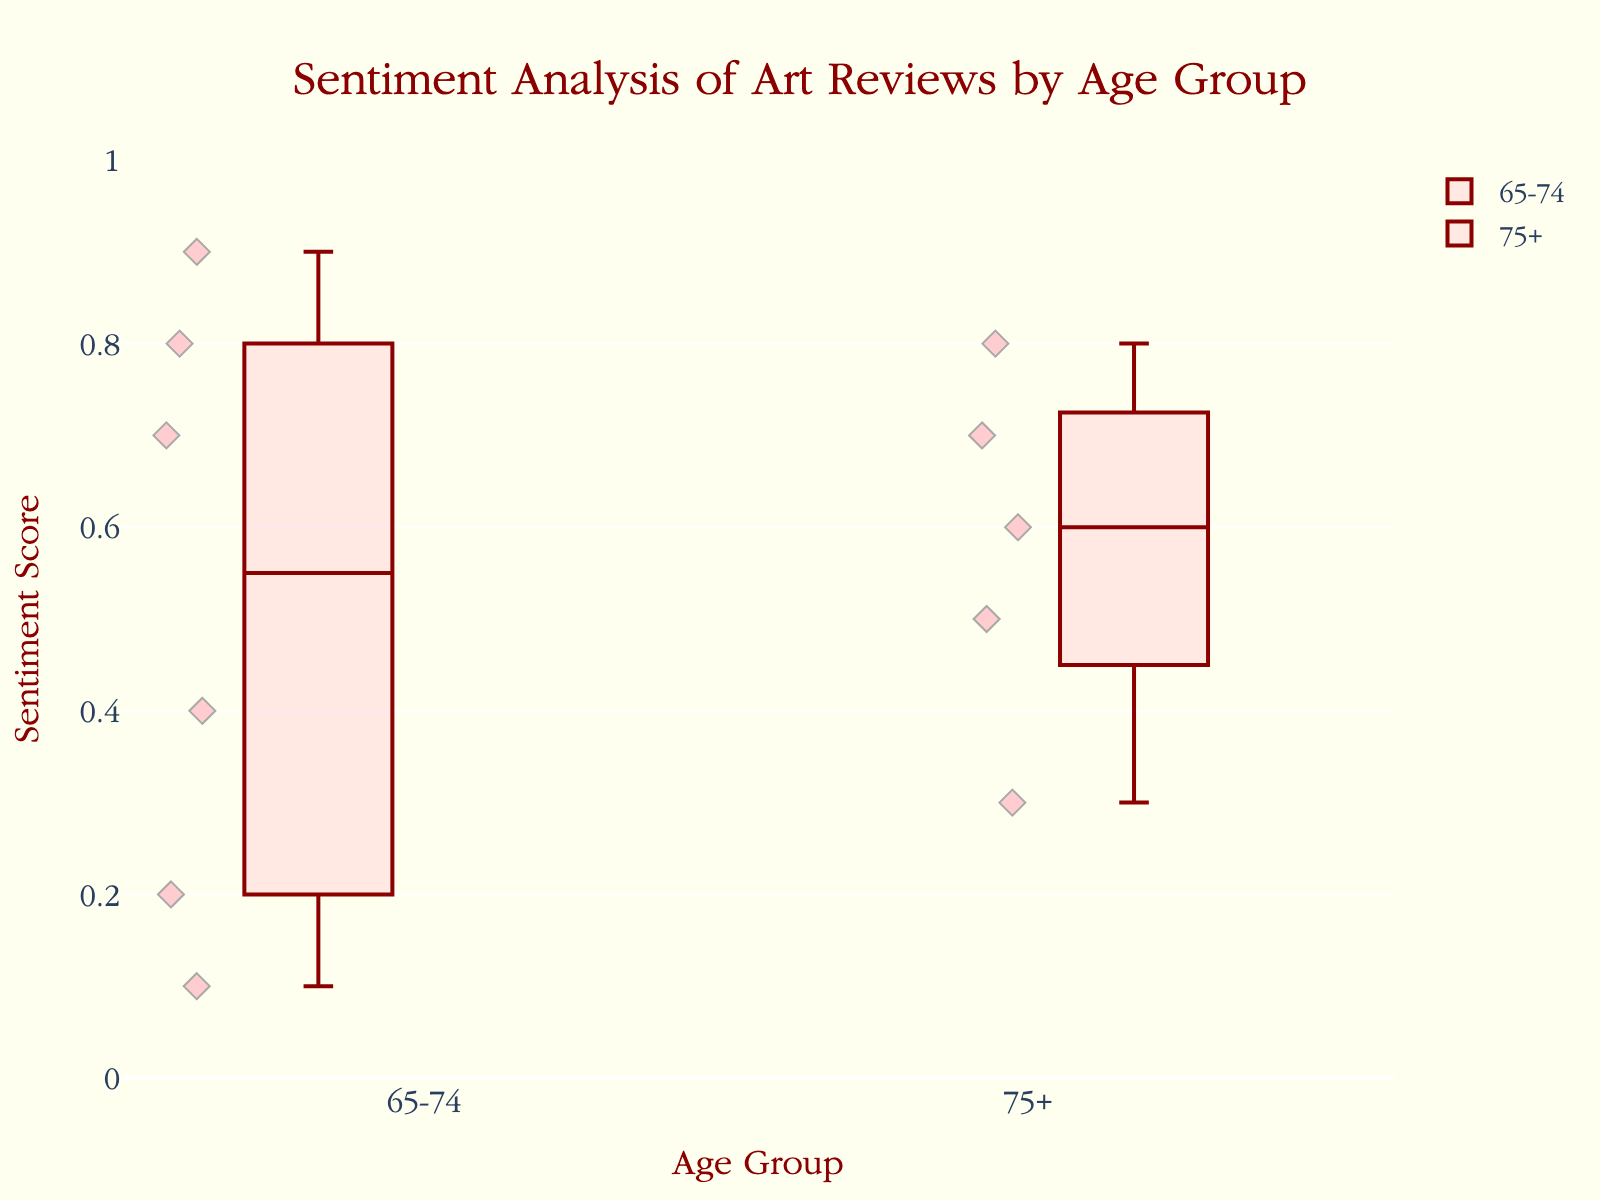what is the title of the plot? The title can be found at the top of the plot, and it reads "Sentiment Analysis of Art Reviews by Age Group."
Answer: Sentiment Analysis of Art Reviews by Age Group How many unique age groups are there? By identifying the different categories on the x-axis, you can see that there are two unique age groups: "65-74" and "75+."
Answer: 2 What is the maximum sentiment score value depicted for the 65-74 age group? Look at the highest point in the box plot under the "65-74" category on the x-axis, which reaches up to 0.9.
Answer: 0.9 Which age group shows a greater median sentiment score? The line inside the box that represents the median score, for the "65-74" group is around 0.55 and for the "75+" group is around 0.6.
Answer: 75+ Are there any outliers in the "65-74" age group? In a box plot, outliers are depicted as individual points that are outside the whiskers. In the "65-74" age group, there is a point at 0.1, which is outside the lower whisker, indicating an outlier.
Answer: Yes What is the range of sentiment scores for the "75+" age group? The range is determined by the distance between the minimum and maximum points within the whiskers. For the "75+" age group, the sentiment scores range from 0.3 to 0.8.
Answer: 0.3 - 0.8 Which age group has a more varied sentiment score? By observing the distance between the minimum and maximum whiskers, it's clear that the "65-74" age group has a wider range (0.1 to 0.9) compared to "75+" (0.3 to 0.8).
Answer: 65-74 What is the interquartile range (IQR) for the "75+" age group? The IQR is the distance between the first quartile (bottom of the box) and the third quartile (top of the box). For the "75+" group, the first quartile is around 0.5 and the third quartile is around 0.75, so the IQR is 0.75 - 0.5 = 0.25.
Answer: 0.25 Compare the distribution spread of sentiment scores between the age groups. The "65-74" age group has a wider spread with more scatter points, indicating higher variability. The "75+" age group has a narrower spread with less variability.
Answer: 65-74 has wider spread 